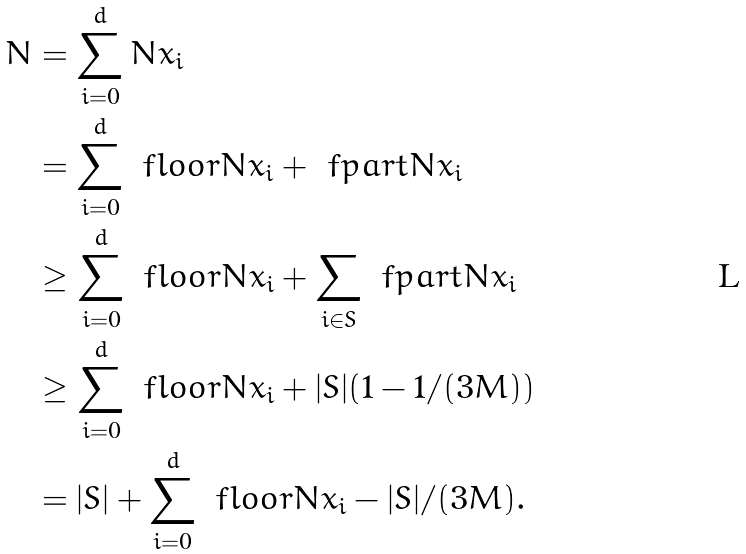<formula> <loc_0><loc_0><loc_500><loc_500>N & = \sum _ { i = 0 } ^ { d } N x _ { i } \\ & = \sum _ { i = 0 } ^ { d } \ f l o o r { N x _ { i } } + \ f p a r t { N x _ { i } } \\ & \geq \sum _ { i = 0 } ^ { d } \ f l o o r { N x _ { i } } + \sum _ { i \in S } \ f p a r t { N x _ { i } } \\ & \geq \sum _ { i = 0 } ^ { d } \ f l o o r { N x _ { i } } + | S | ( 1 - 1 / ( 3 M ) ) \\ & = | S | + \sum _ { i = 0 } ^ { d } \ f l o o r { N x _ { i } } - | S | / ( 3 M ) .</formula> 